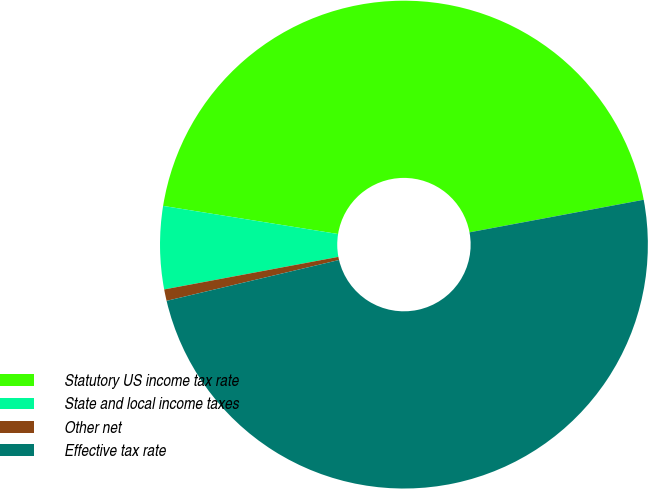Convert chart to OTSL. <chart><loc_0><loc_0><loc_500><loc_500><pie_chart><fcel>Statutory US income tax rate<fcel>State and local income taxes<fcel>Other net<fcel>Effective tax rate<nl><fcel>44.52%<fcel>5.48%<fcel>0.76%<fcel>49.24%<nl></chart> 